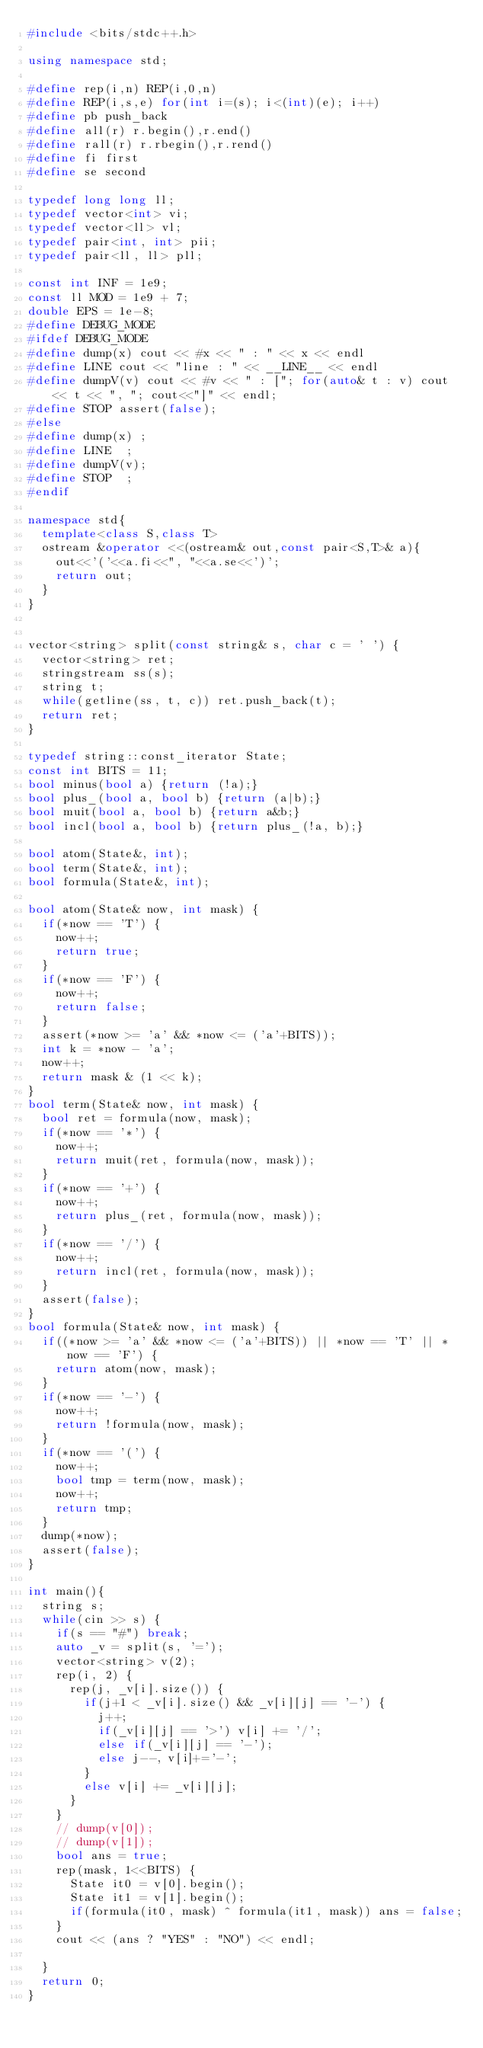Convert code to text. <code><loc_0><loc_0><loc_500><loc_500><_C++_>#include <bits/stdc++.h>
  
using namespace std;
  
#define rep(i,n) REP(i,0,n)
#define REP(i,s,e) for(int i=(s); i<(int)(e); i++)
#define pb push_back
#define all(r) r.begin(),r.end()
#define rall(r) r.rbegin(),r.rend()
#define fi first
#define se second
  
typedef long long ll;
typedef vector<int> vi;
typedef vector<ll> vl;
typedef pair<int, int> pii;
typedef pair<ll, ll> pll;
 
const int INF = 1e9;
const ll MOD = 1e9 + 7;
double EPS = 1e-8;
#define DEBUG_MODE
#ifdef DEBUG_MODE
#define dump(x) cout << #x << " : " << x << endl
#define LINE cout << "line : " << __LINE__ << endl
#define dumpV(v) cout << #v << " : ["; for(auto& t : v) cout << t << ", "; cout<<"]" << endl;
#define STOP assert(false);
#else
#define dump(x) ;
#define LINE 	;
#define dumpV(v);
#define STOP 	;
#endif

namespace std{
  template<class S,class T>
  ostream &operator <<(ostream& out,const pair<S,T>& a){
    out<<'('<<a.fi<<", "<<a.se<<')';
    return out;
  }
}


vector<string> split(const string& s, char c = ' ') {
	vector<string> ret;
	stringstream ss(s);
	string t;
	while(getline(ss, t, c)) ret.push_back(t);
	return ret;
}

typedef string::const_iterator State;
const int BITS = 11;
bool minus(bool a) {return (!a);}
bool plus_(bool a, bool b) {return (a|b);}
bool muit(bool a, bool b) {return a&b;}
bool incl(bool a, bool b) {return plus_(!a, b);}

bool atom(State&, int);
bool term(State&, int);
bool formula(State&, int);

bool atom(State& now, int mask) {
	if(*now == 'T') {
		now++;
		return true;
 	}
 	if(*now == 'F') {
 		now++;
 		return false;
 	}
 	assert(*now >= 'a' && *now <= ('a'+BITS));
 	int k = *now - 'a';
 	now++;
 	return mask & (1 << k);
}
bool term(State& now, int mask) {
	bool ret = formula(now, mask);
	if(*now == '*') {
		now++;
		return muit(ret, formula(now, mask));
	}
	if(*now == '+') {
		now++;
		return plus_(ret, formula(now, mask));
	}
	if(*now == '/') {
		now++;
		return incl(ret, formula(now, mask));
	}
	assert(false);
}
bool formula(State& now, int mask) {
	if((*now >= 'a' && *now <= ('a'+BITS)) || *now == 'T' || *now == 'F') {
		return atom(now, mask);
	}
	if(*now == '-') {
		now++;
		return !formula(now, mask);
	}
	if(*now == '(') {
		now++;
		bool tmp = term(now, mask);
		now++;
		return tmp;
	}
	dump(*now);
	assert(false);
}

int main(){
	string s;
	while(cin >> s) {
		if(s == "#") break;
		auto _v = split(s, '=');
		vector<string> v(2);
		rep(i, 2) {
			rep(j, _v[i].size()) {
				if(j+1 < _v[i].size() && _v[i][j] == '-') {
					j++;
					if(_v[i][j] == '>') v[i] += '/';
					else if(_v[i][j] == '-');
					else j--, v[i]+='-';
				}
				else v[i] += _v[i][j];
			}
		}
		// dump(v[0]);
		// dump(v[1]);
		bool ans = true;
		rep(mask, 1<<BITS) {
			State it0 = v[0].begin();
			State it1 = v[1].begin();
			if(formula(it0, mask) ^ formula(it1, mask)) ans = false;
		}
		cout << (ans ? "YES" : "NO") << endl;
		
	}
	return 0;
}</code> 